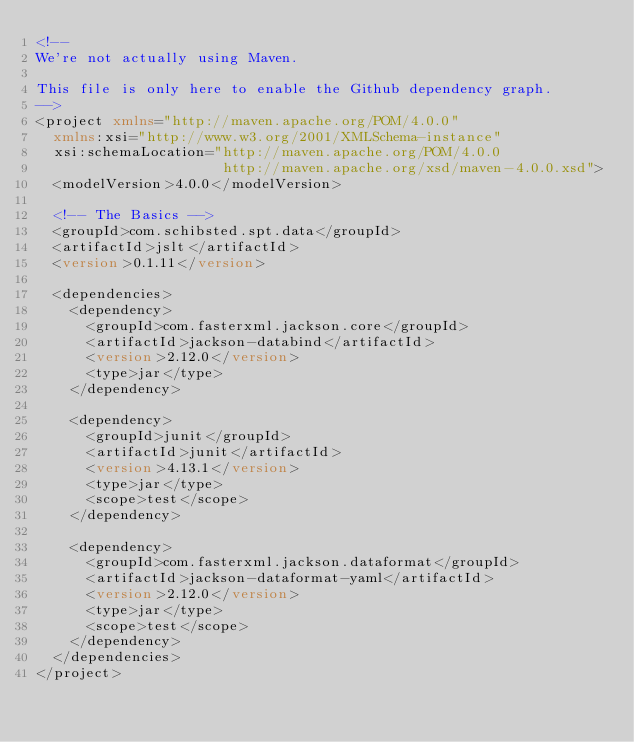Convert code to text. <code><loc_0><loc_0><loc_500><loc_500><_XML_><!--
We're not actually using Maven.

This file is only here to enable the Github dependency graph.
-->
<project xmlns="http://maven.apache.org/POM/4.0.0"
  xmlns:xsi="http://www.w3.org/2001/XMLSchema-instance"
  xsi:schemaLocation="http://maven.apache.org/POM/4.0.0
                      http://maven.apache.org/xsd/maven-4.0.0.xsd">
  <modelVersion>4.0.0</modelVersion>

  <!-- The Basics -->
  <groupId>com.schibsted.spt.data</groupId>
  <artifactId>jslt</artifactId>
  <version>0.1.11</version>

  <dependencies>
    <dependency>
      <groupId>com.fasterxml.jackson.core</groupId>
      <artifactId>jackson-databind</artifactId>
      <version>2.12.0</version>
      <type>jar</type>
    </dependency>

    <dependency>
      <groupId>junit</groupId>
      <artifactId>junit</artifactId>
      <version>4.13.1</version>
      <type>jar</type>
      <scope>test</scope>
    </dependency>

    <dependency>
      <groupId>com.fasterxml.jackson.dataformat</groupId>
      <artifactId>jackson-dataformat-yaml</artifactId>
      <version>2.12.0</version>
      <type>jar</type>
      <scope>test</scope>
    </dependency>
  </dependencies>
</project>
</code> 